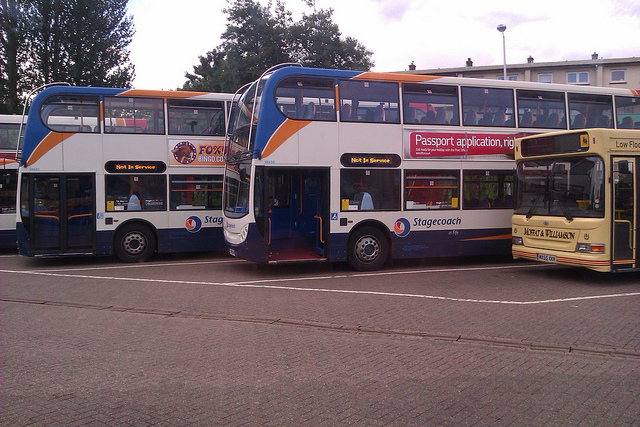Please transcribe the text in this image. Passport application, Stagecoach LOW FOX & FLO RIG HOT stag 